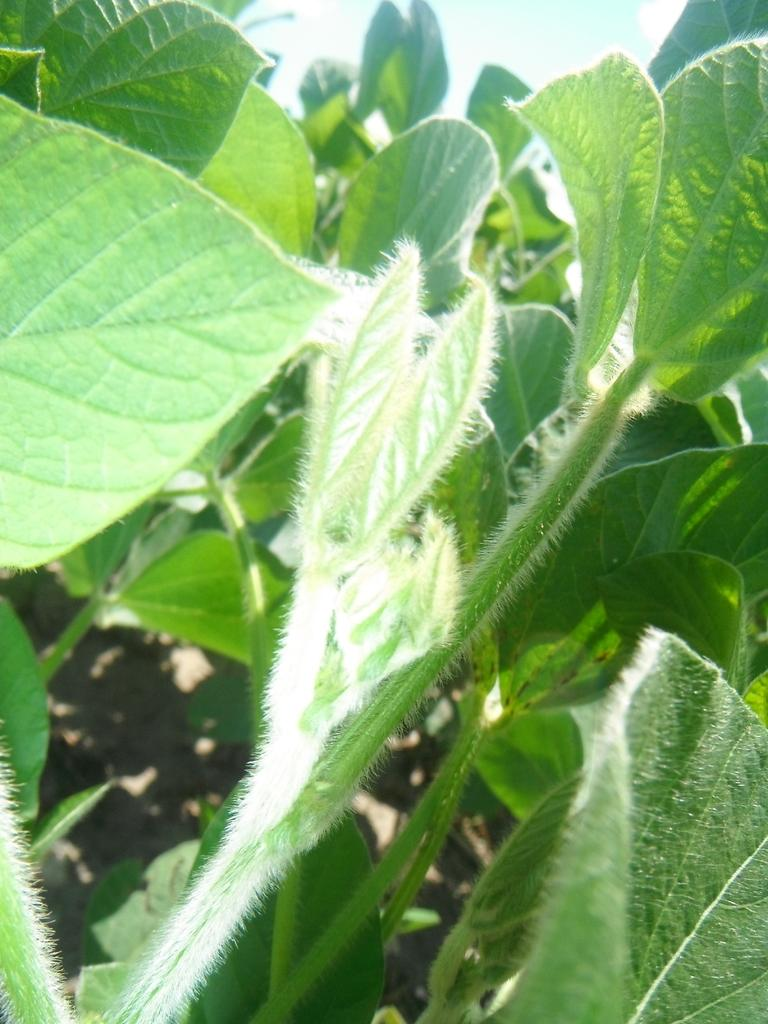Where was the image taken? The image is taken outdoors. What type of vegetation can be seen in the image? There are plants with green leaves and stems in the image. How are the plants positioned in the image? The plants are on the ground. What is visible at the top of the image? The sky is visible at the top of the image. What can be observed about the sky in the image? There are clouds in the sky. Can you tell me how much income the pig generates in the image? There is no pig present in the image, so it is not possible to determine its income. 